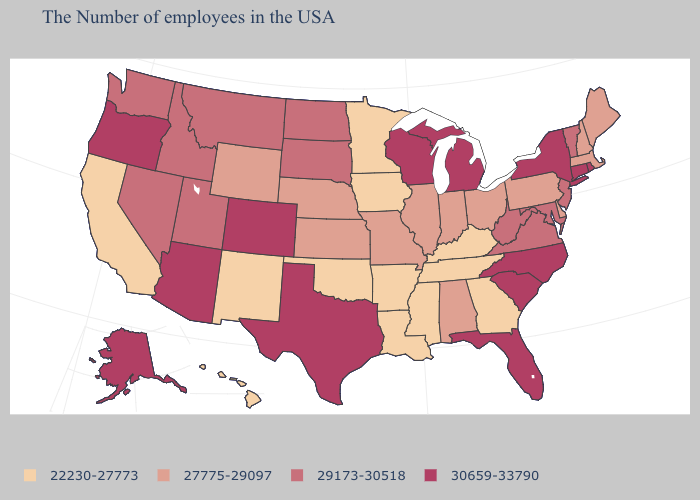What is the value of Kentucky?
Write a very short answer. 22230-27773. Name the states that have a value in the range 30659-33790?
Keep it brief. Rhode Island, Connecticut, New York, North Carolina, South Carolina, Florida, Michigan, Wisconsin, Texas, Colorado, Arizona, Oregon, Alaska. Does Kansas have the highest value in the USA?
Write a very short answer. No. Is the legend a continuous bar?
Give a very brief answer. No. Among the states that border Alabama , which have the highest value?
Concise answer only. Florida. Name the states that have a value in the range 30659-33790?
Give a very brief answer. Rhode Island, Connecticut, New York, North Carolina, South Carolina, Florida, Michigan, Wisconsin, Texas, Colorado, Arizona, Oregon, Alaska. What is the value of New Jersey?
Keep it brief. 29173-30518. Name the states that have a value in the range 22230-27773?
Short answer required. Georgia, Kentucky, Tennessee, Mississippi, Louisiana, Arkansas, Minnesota, Iowa, Oklahoma, New Mexico, California, Hawaii. What is the value of South Carolina?
Answer briefly. 30659-33790. Name the states that have a value in the range 30659-33790?
Write a very short answer. Rhode Island, Connecticut, New York, North Carolina, South Carolina, Florida, Michigan, Wisconsin, Texas, Colorado, Arizona, Oregon, Alaska. Name the states that have a value in the range 29173-30518?
Concise answer only. Vermont, New Jersey, Maryland, Virginia, West Virginia, South Dakota, North Dakota, Utah, Montana, Idaho, Nevada, Washington. Among the states that border Utah , does New Mexico have the lowest value?
Short answer required. Yes. Name the states that have a value in the range 29173-30518?
Write a very short answer. Vermont, New Jersey, Maryland, Virginia, West Virginia, South Dakota, North Dakota, Utah, Montana, Idaho, Nevada, Washington. Name the states that have a value in the range 22230-27773?
Write a very short answer. Georgia, Kentucky, Tennessee, Mississippi, Louisiana, Arkansas, Minnesota, Iowa, Oklahoma, New Mexico, California, Hawaii. Which states have the lowest value in the Northeast?
Answer briefly. Maine, Massachusetts, New Hampshire, Pennsylvania. 